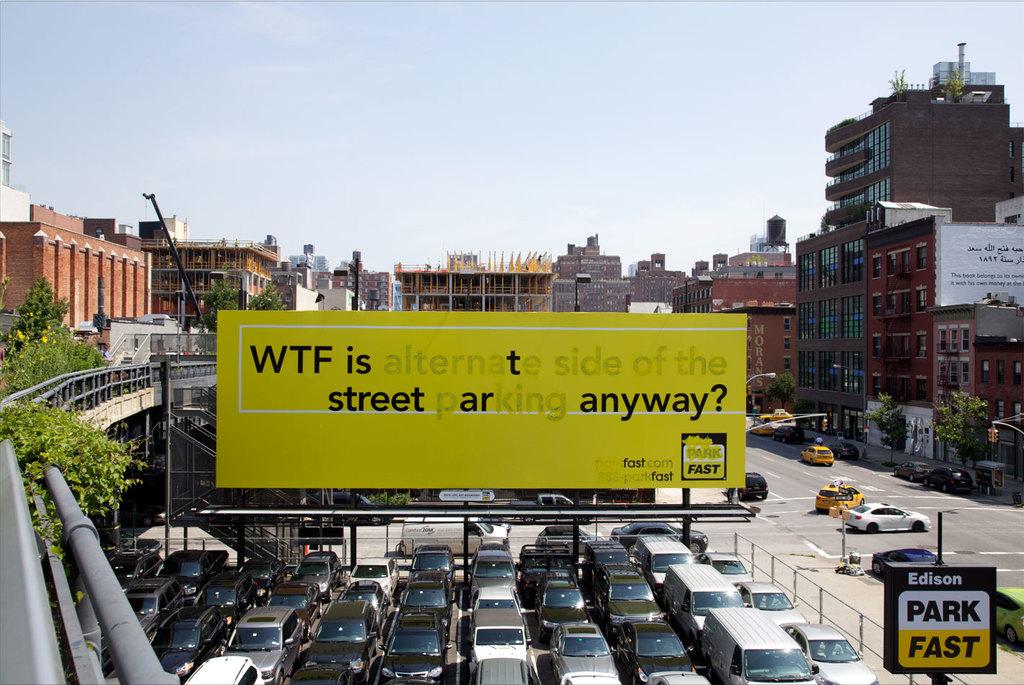Is edison the name of a parking lot?
Ensure brevity in your answer.  Yes. 